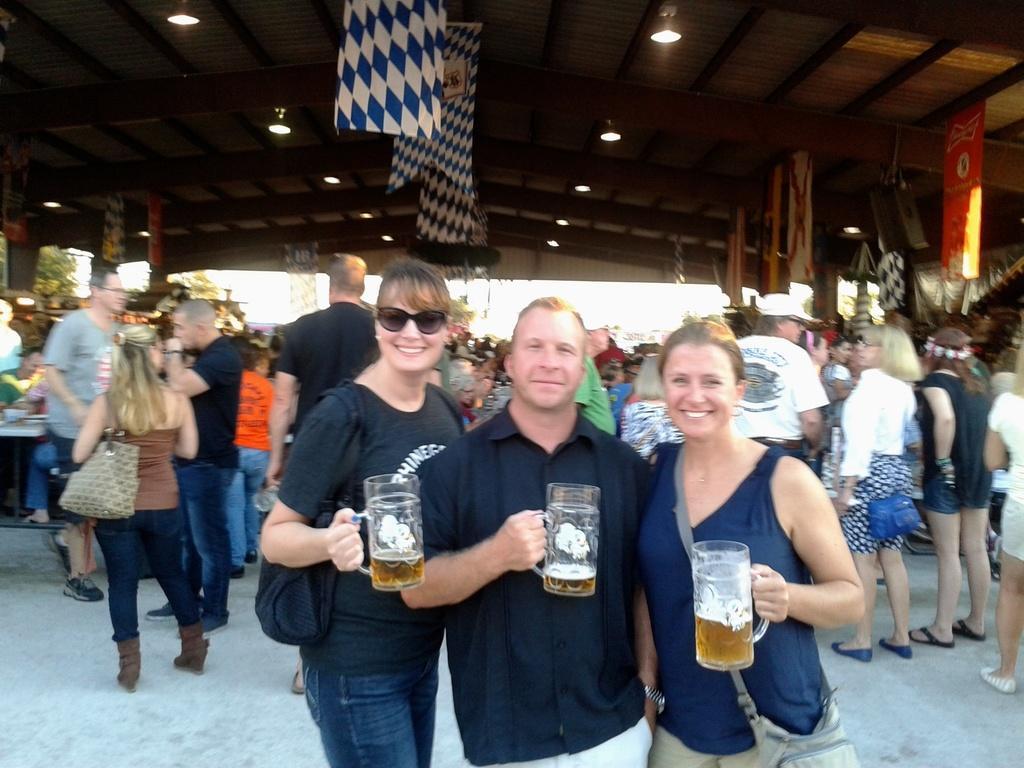Can you describe this image briefly? There are three members standing and holding a glasses in their hands. Two of them were women and the middle one was man. In the background there are some people standing and talking to each other. We can observe lights here. 